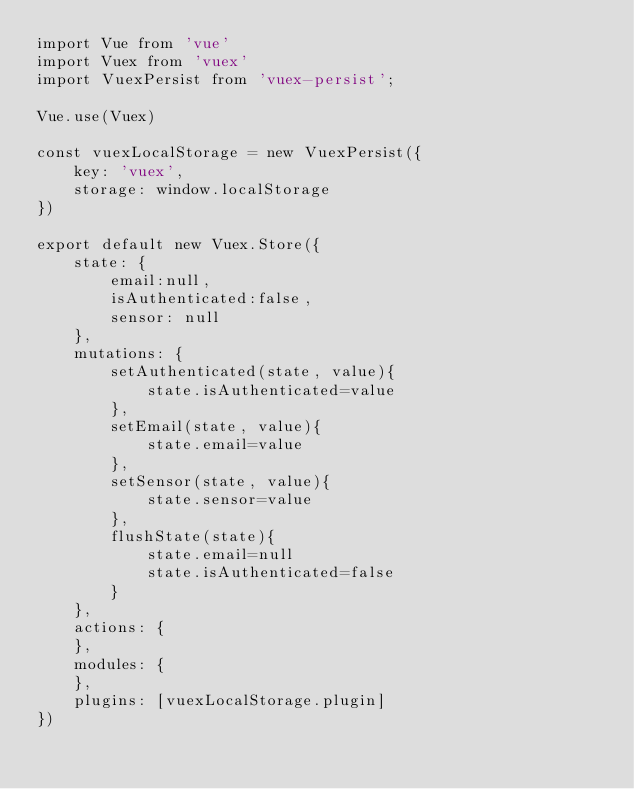<code> <loc_0><loc_0><loc_500><loc_500><_JavaScript_>import Vue from 'vue'
import Vuex from 'vuex'
import VuexPersist from 'vuex-persist';

Vue.use(Vuex)

const vuexLocalStorage = new VuexPersist({
    key: 'vuex',
    storage: window.localStorage
})

export default new Vuex.Store({
    state: {
        email:null,
        isAuthenticated:false,
        sensor: null
    },
    mutations: {
        setAuthenticated(state, value){
            state.isAuthenticated=value
        },
        setEmail(state, value){
            state.email=value
        },
        setSensor(state, value){
            state.sensor=value
        },
        flushState(state){
            state.email=null
            state.isAuthenticated=false
        }
    },
    actions: {
    },
    modules: {
    },
    plugins: [vuexLocalStorage.plugin]
})
</code> 